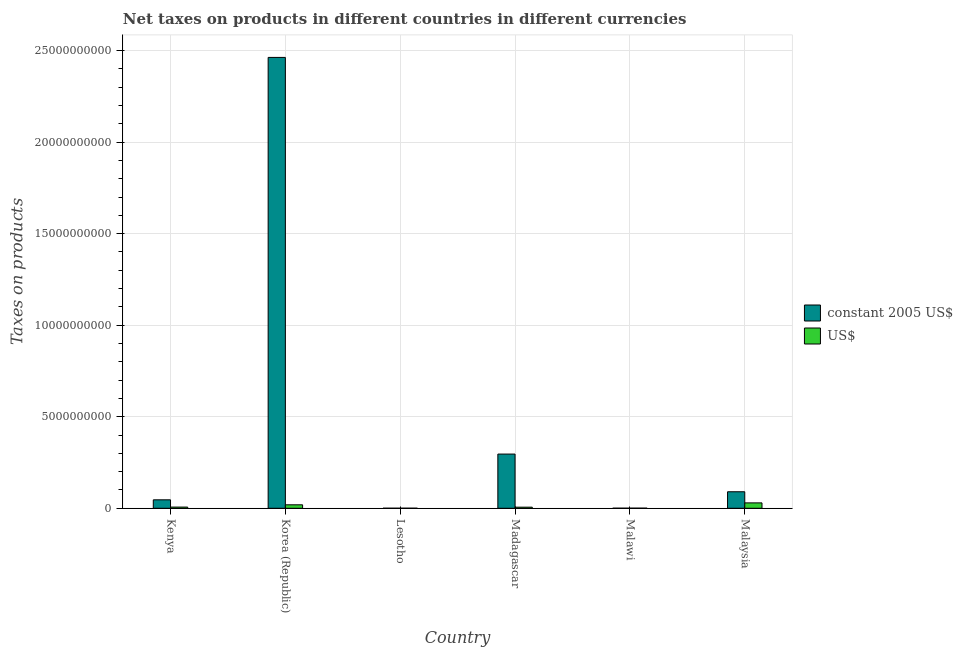How many groups of bars are there?
Ensure brevity in your answer.  6. Are the number of bars on each tick of the X-axis equal?
Offer a very short reply. Yes. How many bars are there on the 2nd tick from the left?
Give a very brief answer. 2. What is the label of the 1st group of bars from the left?
Your answer should be very brief. Kenya. In how many cases, is the number of bars for a given country not equal to the number of legend labels?
Your response must be concise. 0. What is the net taxes in us$ in Korea (Republic)?
Provide a short and direct response. 1.89e+08. Across all countries, what is the maximum net taxes in constant 2005 us$?
Make the answer very short. 2.46e+1. Across all countries, what is the minimum net taxes in constant 2005 us$?
Offer a very short reply. 2.10e+06. In which country was the net taxes in constant 2005 us$ maximum?
Ensure brevity in your answer.  Korea (Republic). In which country was the net taxes in us$ minimum?
Give a very brief answer. Lesotho. What is the total net taxes in constant 2005 us$ in the graph?
Your response must be concise. 2.90e+1. What is the difference between the net taxes in constant 2005 us$ in Kenya and that in Korea (Republic)?
Your answer should be compact. -2.42e+1. What is the difference between the net taxes in constant 2005 us$ in Malaysia and the net taxes in us$ in Kenya?
Offer a terse response. 8.37e+08. What is the average net taxes in constant 2005 us$ per country?
Give a very brief answer. 4.83e+09. What is the difference between the net taxes in constant 2005 us$ and net taxes in us$ in Malawi?
Your answer should be very brief. -1.76e+06. What is the ratio of the net taxes in us$ in Kenya to that in Lesotho?
Keep it short and to the point. 21.99. Is the net taxes in constant 2005 us$ in Korea (Republic) less than that in Malaysia?
Give a very brief answer. No. What is the difference between the highest and the second highest net taxes in us$?
Make the answer very short. 1.05e+08. What is the difference between the highest and the lowest net taxes in us$?
Your response must be concise. 2.92e+08. In how many countries, is the net taxes in constant 2005 us$ greater than the average net taxes in constant 2005 us$ taken over all countries?
Your answer should be compact. 1. What does the 1st bar from the left in Madagascar represents?
Your answer should be compact. Constant 2005 us$. What does the 1st bar from the right in Korea (Republic) represents?
Offer a very short reply. US$. How many bars are there?
Provide a succinct answer. 12. How many countries are there in the graph?
Offer a very short reply. 6. Does the graph contain any zero values?
Give a very brief answer. No. How many legend labels are there?
Ensure brevity in your answer.  2. How are the legend labels stacked?
Your response must be concise. Vertical. What is the title of the graph?
Ensure brevity in your answer.  Net taxes on products in different countries in different currencies. Does "Passenger Transport Items" appear as one of the legend labels in the graph?
Ensure brevity in your answer.  No. What is the label or title of the Y-axis?
Make the answer very short. Taxes on products. What is the Taxes on products of constant 2005 US$ in Kenya?
Your answer should be very brief. 4.62e+08. What is the Taxes on products in US$ in Kenya?
Your response must be concise. 6.47e+07. What is the Taxes on products in constant 2005 US$ in Korea (Republic)?
Give a very brief answer. 2.46e+1. What is the Taxes on products in US$ in Korea (Republic)?
Provide a succinct answer. 1.89e+08. What is the Taxes on products of constant 2005 US$ in Lesotho?
Ensure brevity in your answer.  2.10e+06. What is the Taxes on products of US$ in Lesotho?
Your answer should be very brief. 2.94e+06. What is the Taxes on products of constant 2005 US$ in Madagascar?
Keep it short and to the point. 2.96e+09. What is the Taxes on products of US$ in Madagascar?
Offer a terse response. 6.00e+07. What is the Taxes on products in constant 2005 US$ in Malawi?
Ensure brevity in your answer.  4.40e+06. What is the Taxes on products of US$ in Malawi?
Offer a very short reply. 6.16e+06. What is the Taxes on products of constant 2005 US$ in Malaysia?
Offer a terse response. 9.02e+08. What is the Taxes on products in US$ in Malaysia?
Provide a short and direct response. 2.95e+08. Across all countries, what is the maximum Taxes on products in constant 2005 US$?
Offer a very short reply. 2.46e+1. Across all countries, what is the maximum Taxes on products of US$?
Give a very brief answer. 2.95e+08. Across all countries, what is the minimum Taxes on products in constant 2005 US$?
Provide a succinct answer. 2.10e+06. Across all countries, what is the minimum Taxes on products of US$?
Give a very brief answer. 2.94e+06. What is the total Taxes on products in constant 2005 US$ in the graph?
Your response must be concise. 2.90e+1. What is the total Taxes on products of US$ in the graph?
Offer a terse response. 6.18e+08. What is the difference between the Taxes on products in constant 2005 US$ in Kenya and that in Korea (Republic)?
Offer a very short reply. -2.42e+1. What is the difference between the Taxes on products in US$ in Kenya and that in Korea (Republic)?
Make the answer very short. -1.25e+08. What is the difference between the Taxes on products in constant 2005 US$ in Kenya and that in Lesotho?
Provide a succinct answer. 4.60e+08. What is the difference between the Taxes on products of US$ in Kenya and that in Lesotho?
Offer a very short reply. 6.17e+07. What is the difference between the Taxes on products in constant 2005 US$ in Kenya and that in Madagascar?
Your answer should be very brief. -2.50e+09. What is the difference between the Taxes on products in US$ in Kenya and that in Madagascar?
Ensure brevity in your answer.  4.70e+06. What is the difference between the Taxes on products of constant 2005 US$ in Kenya and that in Malawi?
Provide a short and direct response. 4.57e+08. What is the difference between the Taxes on products in US$ in Kenya and that in Malawi?
Give a very brief answer. 5.85e+07. What is the difference between the Taxes on products of constant 2005 US$ in Kenya and that in Malaysia?
Your answer should be very brief. -4.40e+08. What is the difference between the Taxes on products of US$ in Kenya and that in Malaysia?
Your response must be concise. -2.30e+08. What is the difference between the Taxes on products of constant 2005 US$ in Korea (Republic) and that in Lesotho?
Make the answer very short. 2.46e+1. What is the difference between the Taxes on products of US$ in Korea (Republic) and that in Lesotho?
Offer a terse response. 1.86e+08. What is the difference between the Taxes on products in constant 2005 US$ in Korea (Republic) and that in Madagascar?
Keep it short and to the point. 2.17e+1. What is the difference between the Taxes on products in US$ in Korea (Republic) and that in Madagascar?
Offer a terse response. 1.29e+08. What is the difference between the Taxes on products in constant 2005 US$ in Korea (Republic) and that in Malawi?
Your answer should be compact. 2.46e+1. What is the difference between the Taxes on products in US$ in Korea (Republic) and that in Malawi?
Ensure brevity in your answer.  1.83e+08. What is the difference between the Taxes on products of constant 2005 US$ in Korea (Republic) and that in Malaysia?
Your response must be concise. 2.37e+1. What is the difference between the Taxes on products in US$ in Korea (Republic) and that in Malaysia?
Make the answer very short. -1.05e+08. What is the difference between the Taxes on products in constant 2005 US$ in Lesotho and that in Madagascar?
Give a very brief answer. -2.96e+09. What is the difference between the Taxes on products in US$ in Lesotho and that in Madagascar?
Your answer should be very brief. -5.70e+07. What is the difference between the Taxes on products of constant 2005 US$ in Lesotho and that in Malawi?
Your answer should be compact. -2.30e+06. What is the difference between the Taxes on products in US$ in Lesotho and that in Malawi?
Provide a succinct answer. -3.22e+06. What is the difference between the Taxes on products of constant 2005 US$ in Lesotho and that in Malaysia?
Make the answer very short. -9.00e+08. What is the difference between the Taxes on products of US$ in Lesotho and that in Malaysia?
Offer a very short reply. -2.92e+08. What is the difference between the Taxes on products in constant 2005 US$ in Madagascar and that in Malawi?
Your response must be concise. 2.96e+09. What is the difference between the Taxes on products in US$ in Madagascar and that in Malawi?
Ensure brevity in your answer.  5.38e+07. What is the difference between the Taxes on products of constant 2005 US$ in Madagascar and that in Malaysia?
Your answer should be compact. 2.06e+09. What is the difference between the Taxes on products of US$ in Madagascar and that in Malaysia?
Give a very brief answer. -2.35e+08. What is the difference between the Taxes on products in constant 2005 US$ in Malawi and that in Malaysia?
Provide a succinct answer. -8.97e+08. What is the difference between the Taxes on products of US$ in Malawi and that in Malaysia?
Ensure brevity in your answer.  -2.88e+08. What is the difference between the Taxes on products of constant 2005 US$ in Kenya and the Taxes on products of US$ in Korea (Republic)?
Keep it short and to the point. 2.72e+08. What is the difference between the Taxes on products in constant 2005 US$ in Kenya and the Taxes on products in US$ in Lesotho?
Provide a succinct answer. 4.59e+08. What is the difference between the Taxes on products in constant 2005 US$ in Kenya and the Taxes on products in US$ in Madagascar?
Offer a terse response. 4.02e+08. What is the difference between the Taxes on products of constant 2005 US$ in Kenya and the Taxes on products of US$ in Malawi?
Your answer should be very brief. 4.56e+08. What is the difference between the Taxes on products of constant 2005 US$ in Kenya and the Taxes on products of US$ in Malaysia?
Offer a terse response. 1.67e+08. What is the difference between the Taxes on products in constant 2005 US$ in Korea (Republic) and the Taxes on products in US$ in Lesotho?
Provide a short and direct response. 2.46e+1. What is the difference between the Taxes on products in constant 2005 US$ in Korea (Republic) and the Taxes on products in US$ in Madagascar?
Ensure brevity in your answer.  2.46e+1. What is the difference between the Taxes on products in constant 2005 US$ in Korea (Republic) and the Taxes on products in US$ in Malawi?
Provide a succinct answer. 2.46e+1. What is the difference between the Taxes on products in constant 2005 US$ in Korea (Republic) and the Taxes on products in US$ in Malaysia?
Ensure brevity in your answer.  2.43e+1. What is the difference between the Taxes on products in constant 2005 US$ in Lesotho and the Taxes on products in US$ in Madagascar?
Ensure brevity in your answer.  -5.79e+07. What is the difference between the Taxes on products in constant 2005 US$ in Lesotho and the Taxes on products in US$ in Malawi?
Provide a succinct answer. -4.06e+06. What is the difference between the Taxes on products of constant 2005 US$ in Lesotho and the Taxes on products of US$ in Malaysia?
Give a very brief answer. -2.92e+08. What is the difference between the Taxes on products of constant 2005 US$ in Madagascar and the Taxes on products of US$ in Malawi?
Make the answer very short. 2.95e+09. What is the difference between the Taxes on products of constant 2005 US$ in Madagascar and the Taxes on products of US$ in Malaysia?
Ensure brevity in your answer.  2.67e+09. What is the difference between the Taxes on products in constant 2005 US$ in Malawi and the Taxes on products in US$ in Malaysia?
Provide a succinct answer. -2.90e+08. What is the average Taxes on products in constant 2005 US$ per country?
Ensure brevity in your answer.  4.83e+09. What is the average Taxes on products in US$ per country?
Your answer should be compact. 1.03e+08. What is the difference between the Taxes on products in constant 2005 US$ and Taxes on products in US$ in Kenya?
Provide a short and direct response. 3.97e+08. What is the difference between the Taxes on products of constant 2005 US$ and Taxes on products of US$ in Korea (Republic)?
Your answer should be compact. 2.44e+1. What is the difference between the Taxes on products of constant 2005 US$ and Taxes on products of US$ in Lesotho?
Give a very brief answer. -8.40e+05. What is the difference between the Taxes on products of constant 2005 US$ and Taxes on products of US$ in Madagascar?
Your answer should be very brief. 2.90e+09. What is the difference between the Taxes on products of constant 2005 US$ and Taxes on products of US$ in Malawi?
Give a very brief answer. -1.76e+06. What is the difference between the Taxes on products of constant 2005 US$ and Taxes on products of US$ in Malaysia?
Your answer should be very brief. 6.07e+08. What is the ratio of the Taxes on products in constant 2005 US$ in Kenya to that in Korea (Republic)?
Ensure brevity in your answer.  0.02. What is the ratio of the Taxes on products in US$ in Kenya to that in Korea (Republic)?
Your response must be concise. 0.34. What is the ratio of the Taxes on products of constant 2005 US$ in Kenya to that in Lesotho?
Offer a very short reply. 219.9. What is the ratio of the Taxes on products of US$ in Kenya to that in Lesotho?
Keep it short and to the point. 21.99. What is the ratio of the Taxes on products in constant 2005 US$ in Kenya to that in Madagascar?
Keep it short and to the point. 0.16. What is the ratio of the Taxes on products of US$ in Kenya to that in Madagascar?
Your answer should be compact. 1.08. What is the ratio of the Taxes on products in constant 2005 US$ in Kenya to that in Malawi?
Your response must be concise. 104.95. What is the ratio of the Taxes on products in US$ in Kenya to that in Malawi?
Your answer should be very brief. 10.5. What is the ratio of the Taxes on products of constant 2005 US$ in Kenya to that in Malaysia?
Provide a short and direct response. 0.51. What is the ratio of the Taxes on products in US$ in Kenya to that in Malaysia?
Make the answer very short. 0.22. What is the ratio of the Taxes on products in constant 2005 US$ in Korea (Republic) to that in Lesotho?
Keep it short and to the point. 1.17e+04. What is the ratio of the Taxes on products in US$ in Korea (Republic) to that in Lesotho?
Provide a short and direct response. 64.43. What is the ratio of the Taxes on products in constant 2005 US$ in Korea (Republic) to that in Madagascar?
Your answer should be very brief. 8.32. What is the ratio of the Taxes on products in US$ in Korea (Republic) to that in Madagascar?
Your answer should be compact. 3.16. What is the ratio of the Taxes on products in constant 2005 US$ in Korea (Republic) to that in Malawi?
Give a very brief answer. 5596.72. What is the ratio of the Taxes on products in US$ in Korea (Republic) to that in Malawi?
Provide a succinct answer. 30.75. What is the ratio of the Taxes on products in constant 2005 US$ in Korea (Republic) to that in Malaysia?
Make the answer very short. 27.31. What is the ratio of the Taxes on products of US$ in Korea (Republic) to that in Malaysia?
Offer a terse response. 0.64. What is the ratio of the Taxes on products in constant 2005 US$ in Lesotho to that in Madagascar?
Offer a terse response. 0. What is the ratio of the Taxes on products of US$ in Lesotho to that in Madagascar?
Offer a terse response. 0.05. What is the ratio of the Taxes on products in constant 2005 US$ in Lesotho to that in Malawi?
Keep it short and to the point. 0.48. What is the ratio of the Taxes on products in US$ in Lesotho to that in Malawi?
Provide a short and direct response. 0.48. What is the ratio of the Taxes on products of constant 2005 US$ in Lesotho to that in Malaysia?
Give a very brief answer. 0. What is the ratio of the Taxes on products of constant 2005 US$ in Madagascar to that in Malawi?
Make the answer very short. 672.74. What is the ratio of the Taxes on products of US$ in Madagascar to that in Malawi?
Keep it short and to the point. 9.73. What is the ratio of the Taxes on products in constant 2005 US$ in Madagascar to that in Malaysia?
Offer a very short reply. 3.28. What is the ratio of the Taxes on products of US$ in Madagascar to that in Malaysia?
Your answer should be compact. 0.2. What is the ratio of the Taxes on products in constant 2005 US$ in Malawi to that in Malaysia?
Your answer should be very brief. 0. What is the ratio of the Taxes on products in US$ in Malawi to that in Malaysia?
Keep it short and to the point. 0.02. What is the difference between the highest and the second highest Taxes on products in constant 2005 US$?
Provide a short and direct response. 2.17e+1. What is the difference between the highest and the second highest Taxes on products of US$?
Give a very brief answer. 1.05e+08. What is the difference between the highest and the lowest Taxes on products in constant 2005 US$?
Provide a short and direct response. 2.46e+1. What is the difference between the highest and the lowest Taxes on products in US$?
Give a very brief answer. 2.92e+08. 